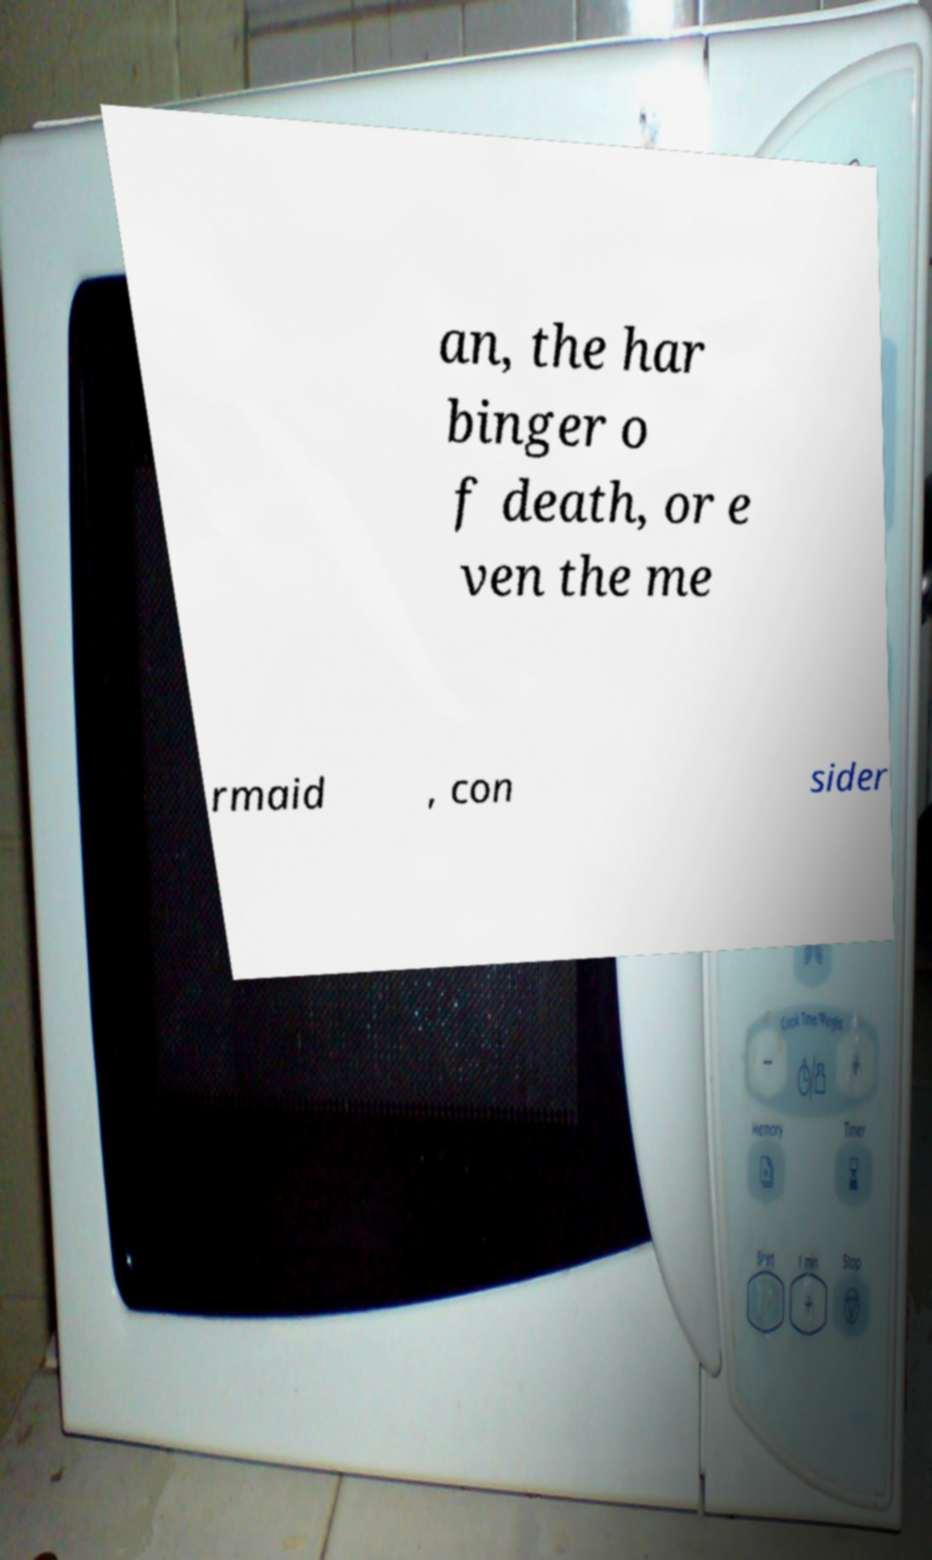Can you accurately transcribe the text from the provided image for me? an, the har binger o f death, or e ven the me rmaid , con sider 